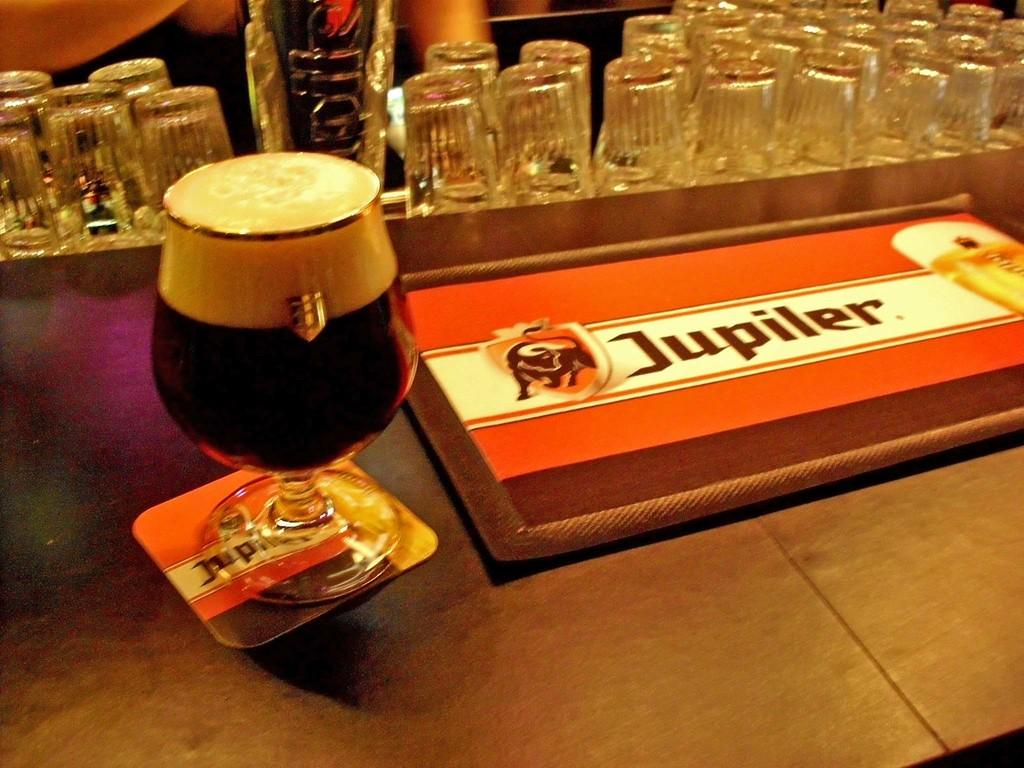Provide a one-sentence caption for the provided image. A glass of Jupiler Beer on the counter at a bar. 